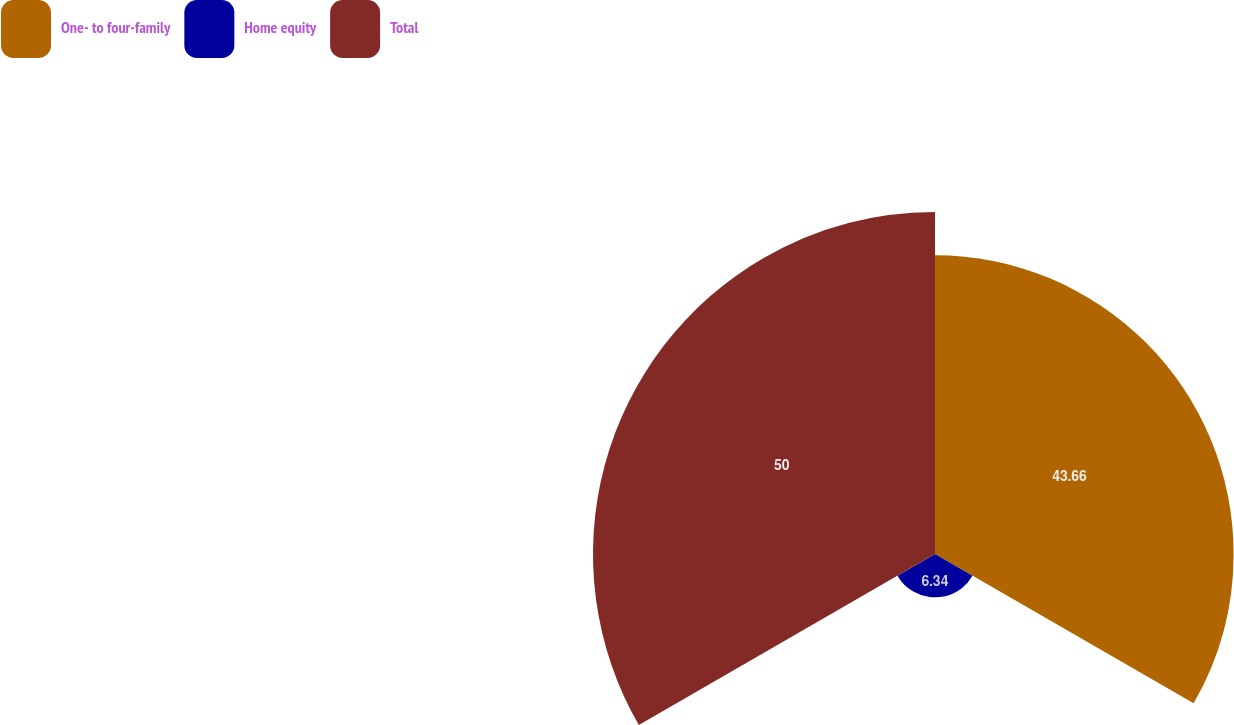Convert chart to OTSL. <chart><loc_0><loc_0><loc_500><loc_500><pie_chart><fcel>One- to four-family<fcel>Home equity<fcel>Total<nl><fcel>43.66%<fcel>6.34%<fcel>50.0%<nl></chart> 